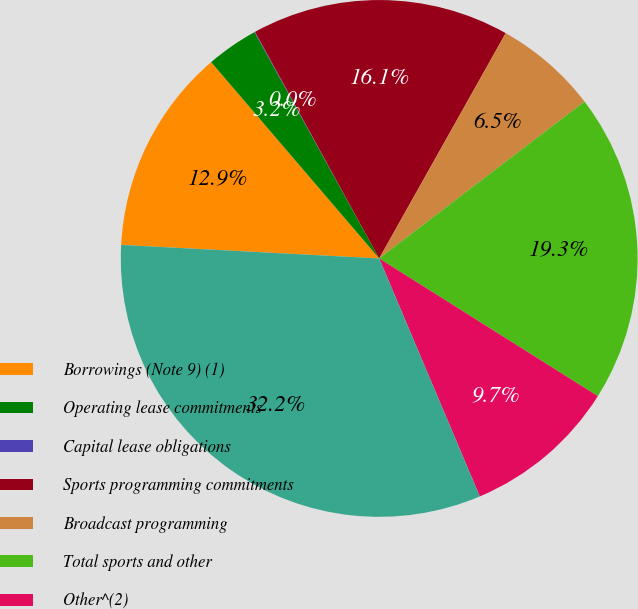Convert chart to OTSL. <chart><loc_0><loc_0><loc_500><loc_500><pie_chart><fcel>Borrowings (Note 9) (1)<fcel>Operating lease commitments<fcel>Capital lease obligations<fcel>Sports programming commitments<fcel>Broadcast programming<fcel>Total sports and other<fcel>Other^(2)<fcel>Total contractual obligations<nl><fcel>12.9%<fcel>3.25%<fcel>0.04%<fcel>16.12%<fcel>6.47%<fcel>19.33%<fcel>9.69%<fcel>32.2%<nl></chart> 